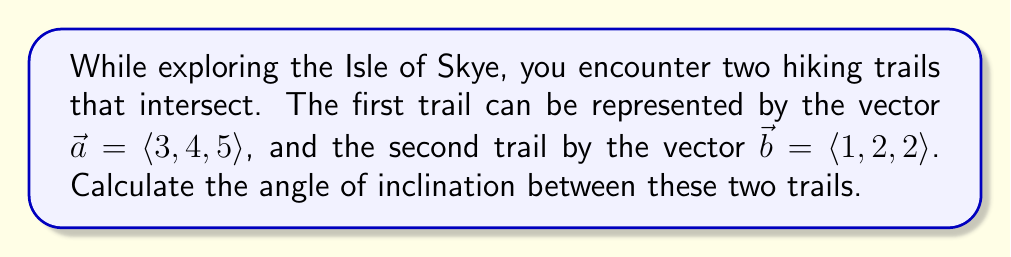Give your solution to this math problem. To find the angle between two vectors, we can use the dot product formula:

$$\cos \theta = \frac{\vec{a} \cdot \vec{b}}{|\vec{a}||\vec{b}|}$$

Let's break this down step-by-step:

1. Calculate the dot product $\vec{a} \cdot \vec{b}$:
   $$\vec{a} \cdot \vec{b} = (3)(1) + (4)(2) + (5)(2) = 3 + 8 + 10 = 21$$

2. Calculate the magnitudes of $\vec{a}$ and $\vec{b}$:
   $$|\vec{a}| = \sqrt{3^2 + 4^2 + 5^2} = \sqrt{9 + 16 + 25} = \sqrt{50}$$
   $$|\vec{b}| = \sqrt{1^2 + 2^2 + 2^2} = \sqrt{1 + 4 + 4} = 3$$

3. Substitute these values into the formula:
   $$\cos \theta = \frac{21}{\sqrt{50} \cdot 3}$$

4. Simplify:
   $$\cos \theta = \frac{21}{3\sqrt{50}} = \frac{7}{\sqrt{50}}$$

5. To find $\theta$, we need to take the inverse cosine (arccos) of both sides:
   $$\theta = \arccos\left(\frac{7}{\sqrt{50}}\right)$$

6. Calculate this value (you can use a calculator for this step):
   $$\theta \approx 0.5769 \text{ radians}$$

7. Convert to degrees:
   $$\theta \approx 0.5769 \cdot \frac{180}{\pi} \approx 33.06°$$

Therefore, the angle of inclination between the two trails is approximately 33.06°.
Answer: The angle of inclination between the two trails is approximately 33.06°. 